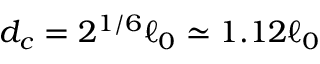Convert formula to latex. <formula><loc_0><loc_0><loc_500><loc_500>d _ { c } = 2 ^ { 1 / 6 } \ell _ { 0 } \simeq 1 . 1 2 \ell _ { 0 }</formula> 